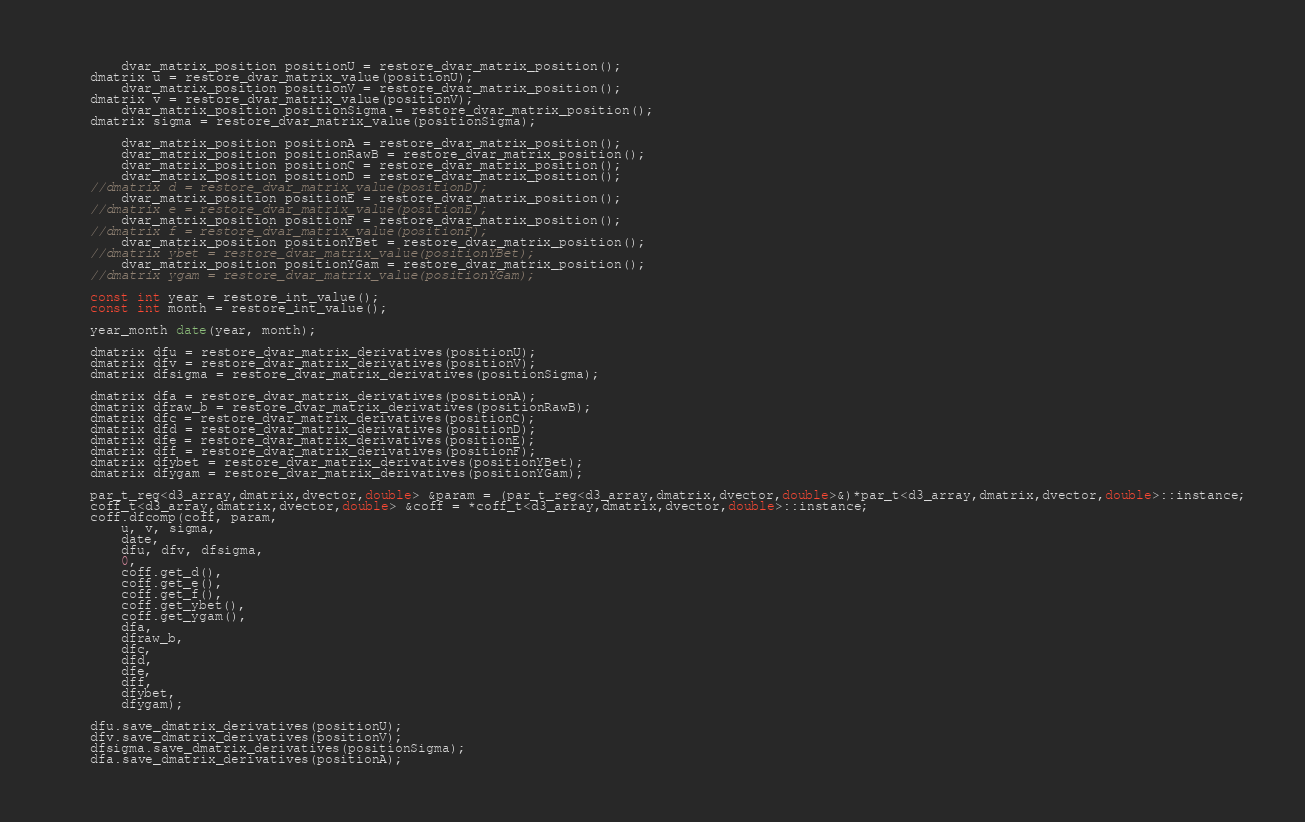Convert code to text. <code><loc_0><loc_0><loc_500><loc_500><_C++_>        dvar_matrix_position positionU = restore_dvar_matrix_position();
	dmatrix u = restore_dvar_matrix_value(positionU);
        dvar_matrix_position positionV = restore_dvar_matrix_position();
	dmatrix v = restore_dvar_matrix_value(positionV);
        dvar_matrix_position positionSigma = restore_dvar_matrix_position();
	dmatrix sigma = restore_dvar_matrix_value(positionSigma);

        dvar_matrix_position positionA = restore_dvar_matrix_position();
        dvar_matrix_position positionRawB = restore_dvar_matrix_position();
        dvar_matrix_position positionC = restore_dvar_matrix_position();
        dvar_matrix_position positionD = restore_dvar_matrix_position();
	//dmatrix d = restore_dvar_matrix_value(positionD);
        dvar_matrix_position positionE = restore_dvar_matrix_position();
	//dmatrix e = restore_dvar_matrix_value(positionE);
        dvar_matrix_position positionF = restore_dvar_matrix_position();
	//dmatrix f = restore_dvar_matrix_value(positionF);
        dvar_matrix_position positionYBet = restore_dvar_matrix_position();
	//dmatrix ybet = restore_dvar_matrix_value(positionYBet);
        dvar_matrix_position positionYGam = restore_dvar_matrix_position();
	//dmatrix ygam = restore_dvar_matrix_value(positionYGam);

	const int year = restore_int_value();
	const int month = restore_int_value();

	year_month date(year, month);

	dmatrix dfu = restore_dvar_matrix_derivatives(positionU);
	dmatrix dfv = restore_dvar_matrix_derivatives(positionV);
	dmatrix dfsigma = restore_dvar_matrix_derivatives(positionSigma);

	dmatrix dfa = restore_dvar_matrix_derivatives(positionA);
	dmatrix dfraw_b = restore_dvar_matrix_derivatives(positionRawB);
	dmatrix dfc = restore_dvar_matrix_derivatives(positionC);
	dmatrix dfd = restore_dvar_matrix_derivatives(positionD);
	dmatrix dfe = restore_dvar_matrix_derivatives(positionE);
	dmatrix dff = restore_dvar_matrix_derivatives(positionF);
	dmatrix dfybet = restore_dvar_matrix_derivatives(positionYBet);
	dmatrix dfygam = restore_dvar_matrix_derivatives(positionYGam);

	par_t_reg<d3_array,dmatrix,dvector,double> &param = (par_t_reg<d3_array,dmatrix,dvector,double>&)*par_t<d3_array,dmatrix,dvector,double>::instance;
	coff_t<d3_array,dmatrix,dvector,double> &coff = *coff_t<d3_array,dmatrix,dvector,double>::instance;
	coff.dfcomp(coff, param,
		u, v, sigma,
		date, 
		dfu, dfv, dfsigma,
		0,
		coff.get_d(),
		coff.get_e(),
		coff.get_f(),
		coff.get_ybet(),
		coff.get_ygam(),
		dfa,
		dfraw_b,
		dfc,
		dfd,
		dfe,
		dff,
		dfybet,
		dfygam);

	dfu.save_dmatrix_derivatives(positionU);
	dfv.save_dmatrix_derivatives(positionV);
	dfsigma.save_dmatrix_derivatives(positionSigma);
	dfa.save_dmatrix_derivatives(positionA);</code> 